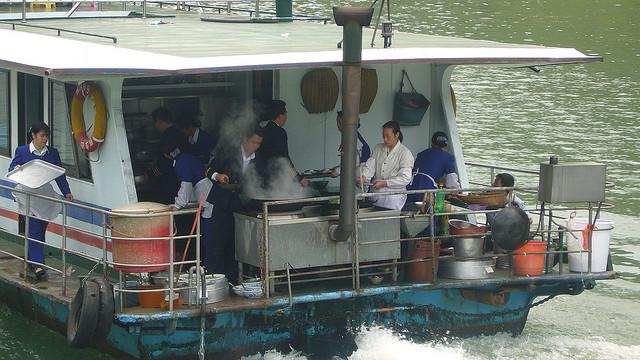How many people are wearing blue?
Keep it brief. 5. What are the people doing?
Be succinct. Cooking. Are they having a party?
Be succinct. Yes. 